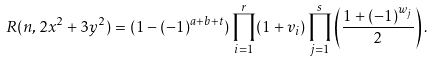<formula> <loc_0><loc_0><loc_500><loc_500>R ( n , 2 x ^ { 2 } + 3 y ^ { 2 } ) = ( 1 - ( - 1 ) ^ { a + b + t } ) \prod _ { i = 1 } ^ { r } ( 1 + v _ { i } ) \prod _ { j = 1 } ^ { s } \left ( \frac { 1 + ( - 1 ) ^ { w _ { j } } } { 2 } \right ) .</formula> 